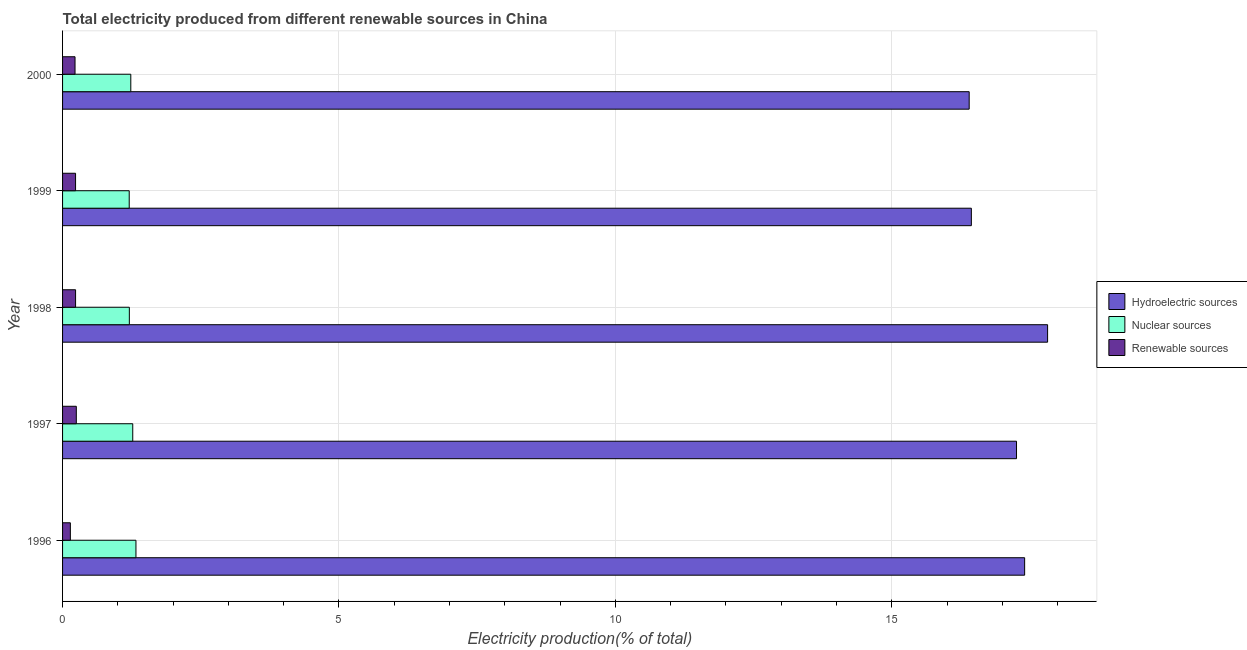How many different coloured bars are there?
Your answer should be compact. 3. Are the number of bars per tick equal to the number of legend labels?
Ensure brevity in your answer.  Yes. What is the label of the 3rd group of bars from the top?
Your answer should be compact. 1998. In how many cases, is the number of bars for a given year not equal to the number of legend labels?
Your answer should be very brief. 0. What is the percentage of electricity produced by hydroelectric sources in 2000?
Ensure brevity in your answer.  16.4. Across all years, what is the maximum percentage of electricity produced by nuclear sources?
Your answer should be compact. 1.33. Across all years, what is the minimum percentage of electricity produced by nuclear sources?
Your answer should be very brief. 1.21. In which year was the percentage of electricity produced by nuclear sources maximum?
Ensure brevity in your answer.  1996. In which year was the percentage of electricity produced by renewable sources minimum?
Offer a terse response. 1996. What is the total percentage of electricity produced by hydroelectric sources in the graph?
Your answer should be very brief. 85.31. What is the difference between the percentage of electricity produced by hydroelectric sources in 1998 and that in 2000?
Keep it short and to the point. 1.42. What is the difference between the percentage of electricity produced by nuclear sources in 2000 and the percentage of electricity produced by renewable sources in 1996?
Your answer should be very brief. 1.09. What is the average percentage of electricity produced by hydroelectric sources per year?
Ensure brevity in your answer.  17.06. In the year 1996, what is the difference between the percentage of electricity produced by renewable sources and percentage of electricity produced by nuclear sources?
Offer a very short reply. -1.19. What is the ratio of the percentage of electricity produced by renewable sources in 1999 to that in 2000?
Offer a terse response. 1.04. Is the percentage of electricity produced by hydroelectric sources in 1997 less than that in 1999?
Your response must be concise. No. Is the difference between the percentage of electricity produced by renewable sources in 1997 and 1998 greater than the difference between the percentage of electricity produced by hydroelectric sources in 1997 and 1998?
Your answer should be very brief. Yes. What is the difference between the highest and the second highest percentage of electricity produced by renewable sources?
Give a very brief answer. 0.01. What is the difference between the highest and the lowest percentage of electricity produced by renewable sources?
Your response must be concise. 0.11. Is the sum of the percentage of electricity produced by renewable sources in 1997 and 1999 greater than the maximum percentage of electricity produced by nuclear sources across all years?
Give a very brief answer. No. What does the 3rd bar from the top in 1999 represents?
Your answer should be very brief. Hydroelectric sources. What does the 2nd bar from the bottom in 1999 represents?
Ensure brevity in your answer.  Nuclear sources. Is it the case that in every year, the sum of the percentage of electricity produced by hydroelectric sources and percentage of electricity produced by nuclear sources is greater than the percentage of electricity produced by renewable sources?
Your response must be concise. Yes. How many years are there in the graph?
Provide a short and direct response. 5. What is the difference between two consecutive major ticks on the X-axis?
Ensure brevity in your answer.  5. Are the values on the major ticks of X-axis written in scientific E-notation?
Offer a terse response. No. Does the graph contain any zero values?
Ensure brevity in your answer.  No. Does the graph contain grids?
Give a very brief answer. Yes. How many legend labels are there?
Give a very brief answer. 3. What is the title of the graph?
Your response must be concise. Total electricity produced from different renewable sources in China. What is the label or title of the Y-axis?
Your response must be concise. Year. What is the Electricity production(% of total) of Hydroelectric sources in 1996?
Ensure brevity in your answer.  17.4. What is the Electricity production(% of total) of Nuclear sources in 1996?
Provide a short and direct response. 1.33. What is the Electricity production(% of total) of Renewable sources in 1996?
Ensure brevity in your answer.  0.14. What is the Electricity production(% of total) of Hydroelectric sources in 1997?
Give a very brief answer. 17.26. What is the Electricity production(% of total) in Nuclear sources in 1997?
Provide a short and direct response. 1.27. What is the Electricity production(% of total) in Renewable sources in 1997?
Offer a very short reply. 0.25. What is the Electricity production(% of total) of Hydroelectric sources in 1998?
Provide a succinct answer. 17.82. What is the Electricity production(% of total) of Nuclear sources in 1998?
Your answer should be compact. 1.21. What is the Electricity production(% of total) of Renewable sources in 1998?
Give a very brief answer. 0.24. What is the Electricity production(% of total) in Hydroelectric sources in 1999?
Offer a very short reply. 16.44. What is the Electricity production(% of total) of Nuclear sources in 1999?
Your answer should be compact. 1.21. What is the Electricity production(% of total) of Renewable sources in 1999?
Your answer should be compact. 0.24. What is the Electricity production(% of total) in Hydroelectric sources in 2000?
Offer a very short reply. 16.4. What is the Electricity production(% of total) of Nuclear sources in 2000?
Provide a succinct answer. 1.23. What is the Electricity production(% of total) in Renewable sources in 2000?
Make the answer very short. 0.23. Across all years, what is the maximum Electricity production(% of total) of Hydroelectric sources?
Your response must be concise. 17.82. Across all years, what is the maximum Electricity production(% of total) in Nuclear sources?
Your answer should be very brief. 1.33. Across all years, what is the maximum Electricity production(% of total) in Renewable sources?
Provide a succinct answer. 0.25. Across all years, what is the minimum Electricity production(% of total) of Hydroelectric sources?
Your response must be concise. 16.4. Across all years, what is the minimum Electricity production(% of total) of Nuclear sources?
Keep it short and to the point. 1.21. Across all years, what is the minimum Electricity production(% of total) in Renewable sources?
Provide a succinct answer. 0.14. What is the total Electricity production(% of total) in Hydroelectric sources in the graph?
Ensure brevity in your answer.  85.31. What is the total Electricity production(% of total) of Nuclear sources in the graph?
Provide a succinct answer. 6.24. What is the total Electricity production(% of total) of Renewable sources in the graph?
Provide a short and direct response. 1.09. What is the difference between the Electricity production(% of total) of Hydroelectric sources in 1996 and that in 1997?
Offer a very short reply. 0.15. What is the difference between the Electricity production(% of total) of Nuclear sources in 1996 and that in 1997?
Offer a very short reply. 0.06. What is the difference between the Electricity production(% of total) in Renewable sources in 1996 and that in 1997?
Your response must be concise. -0.11. What is the difference between the Electricity production(% of total) in Hydroelectric sources in 1996 and that in 1998?
Keep it short and to the point. -0.42. What is the difference between the Electricity production(% of total) in Nuclear sources in 1996 and that in 1998?
Give a very brief answer. 0.12. What is the difference between the Electricity production(% of total) in Renewable sources in 1996 and that in 1998?
Your answer should be very brief. -0.09. What is the difference between the Electricity production(% of total) in Hydroelectric sources in 1996 and that in 1999?
Your response must be concise. 0.96. What is the difference between the Electricity production(% of total) in Nuclear sources in 1996 and that in 1999?
Make the answer very short. 0.12. What is the difference between the Electricity production(% of total) of Renewable sources in 1996 and that in 1999?
Your answer should be compact. -0.09. What is the difference between the Electricity production(% of total) in Hydroelectric sources in 1996 and that in 2000?
Provide a short and direct response. 1. What is the difference between the Electricity production(% of total) in Nuclear sources in 1996 and that in 2000?
Your response must be concise. 0.09. What is the difference between the Electricity production(% of total) of Renewable sources in 1996 and that in 2000?
Offer a very short reply. -0.08. What is the difference between the Electricity production(% of total) of Hydroelectric sources in 1997 and that in 1998?
Ensure brevity in your answer.  -0.56. What is the difference between the Electricity production(% of total) in Nuclear sources in 1997 and that in 1998?
Your response must be concise. 0.06. What is the difference between the Electricity production(% of total) in Renewable sources in 1997 and that in 1998?
Keep it short and to the point. 0.01. What is the difference between the Electricity production(% of total) of Hydroelectric sources in 1997 and that in 1999?
Give a very brief answer. 0.82. What is the difference between the Electricity production(% of total) in Nuclear sources in 1997 and that in 1999?
Make the answer very short. 0.06. What is the difference between the Electricity production(% of total) in Renewable sources in 1997 and that in 1999?
Offer a terse response. 0.01. What is the difference between the Electricity production(% of total) in Hydroelectric sources in 1997 and that in 2000?
Give a very brief answer. 0.86. What is the difference between the Electricity production(% of total) of Nuclear sources in 1997 and that in 2000?
Provide a short and direct response. 0.04. What is the difference between the Electricity production(% of total) in Renewable sources in 1997 and that in 2000?
Offer a very short reply. 0.02. What is the difference between the Electricity production(% of total) of Hydroelectric sources in 1998 and that in 1999?
Keep it short and to the point. 1.38. What is the difference between the Electricity production(% of total) in Nuclear sources in 1998 and that in 1999?
Provide a succinct answer. 0. What is the difference between the Electricity production(% of total) in Hydroelectric sources in 1998 and that in 2000?
Provide a succinct answer. 1.42. What is the difference between the Electricity production(% of total) in Nuclear sources in 1998 and that in 2000?
Your response must be concise. -0.03. What is the difference between the Electricity production(% of total) of Renewable sources in 1998 and that in 2000?
Keep it short and to the point. 0.01. What is the difference between the Electricity production(% of total) of Hydroelectric sources in 1999 and that in 2000?
Your answer should be compact. 0.04. What is the difference between the Electricity production(% of total) of Nuclear sources in 1999 and that in 2000?
Provide a succinct answer. -0.03. What is the difference between the Electricity production(% of total) of Renewable sources in 1999 and that in 2000?
Provide a short and direct response. 0.01. What is the difference between the Electricity production(% of total) in Hydroelectric sources in 1996 and the Electricity production(% of total) in Nuclear sources in 1997?
Offer a terse response. 16.13. What is the difference between the Electricity production(% of total) in Hydroelectric sources in 1996 and the Electricity production(% of total) in Renewable sources in 1997?
Ensure brevity in your answer.  17.15. What is the difference between the Electricity production(% of total) of Nuclear sources in 1996 and the Electricity production(% of total) of Renewable sources in 1997?
Offer a terse response. 1.08. What is the difference between the Electricity production(% of total) of Hydroelectric sources in 1996 and the Electricity production(% of total) of Nuclear sources in 1998?
Your answer should be compact. 16.19. What is the difference between the Electricity production(% of total) of Hydroelectric sources in 1996 and the Electricity production(% of total) of Renewable sources in 1998?
Keep it short and to the point. 17.17. What is the difference between the Electricity production(% of total) in Nuclear sources in 1996 and the Electricity production(% of total) in Renewable sources in 1998?
Offer a very short reply. 1.09. What is the difference between the Electricity production(% of total) in Hydroelectric sources in 1996 and the Electricity production(% of total) in Nuclear sources in 1999?
Your answer should be very brief. 16.2. What is the difference between the Electricity production(% of total) in Hydroelectric sources in 1996 and the Electricity production(% of total) in Renewable sources in 1999?
Provide a short and direct response. 17.17. What is the difference between the Electricity production(% of total) of Nuclear sources in 1996 and the Electricity production(% of total) of Renewable sources in 1999?
Your response must be concise. 1.09. What is the difference between the Electricity production(% of total) in Hydroelectric sources in 1996 and the Electricity production(% of total) in Nuclear sources in 2000?
Make the answer very short. 16.17. What is the difference between the Electricity production(% of total) of Hydroelectric sources in 1996 and the Electricity production(% of total) of Renewable sources in 2000?
Give a very brief answer. 17.18. What is the difference between the Electricity production(% of total) of Nuclear sources in 1996 and the Electricity production(% of total) of Renewable sources in 2000?
Provide a succinct answer. 1.1. What is the difference between the Electricity production(% of total) in Hydroelectric sources in 1997 and the Electricity production(% of total) in Nuclear sources in 1998?
Provide a short and direct response. 16.05. What is the difference between the Electricity production(% of total) in Hydroelectric sources in 1997 and the Electricity production(% of total) in Renewable sources in 1998?
Provide a short and direct response. 17.02. What is the difference between the Electricity production(% of total) of Nuclear sources in 1997 and the Electricity production(% of total) of Renewable sources in 1998?
Ensure brevity in your answer.  1.03. What is the difference between the Electricity production(% of total) in Hydroelectric sources in 1997 and the Electricity production(% of total) in Nuclear sources in 1999?
Provide a succinct answer. 16.05. What is the difference between the Electricity production(% of total) in Hydroelectric sources in 1997 and the Electricity production(% of total) in Renewable sources in 1999?
Your answer should be compact. 17.02. What is the difference between the Electricity production(% of total) in Nuclear sources in 1997 and the Electricity production(% of total) in Renewable sources in 1999?
Your answer should be compact. 1.03. What is the difference between the Electricity production(% of total) of Hydroelectric sources in 1997 and the Electricity production(% of total) of Nuclear sources in 2000?
Your response must be concise. 16.02. What is the difference between the Electricity production(% of total) in Hydroelectric sources in 1997 and the Electricity production(% of total) in Renewable sources in 2000?
Offer a terse response. 17.03. What is the difference between the Electricity production(% of total) in Nuclear sources in 1997 and the Electricity production(% of total) in Renewable sources in 2000?
Offer a terse response. 1.04. What is the difference between the Electricity production(% of total) of Hydroelectric sources in 1998 and the Electricity production(% of total) of Nuclear sources in 1999?
Your answer should be compact. 16.61. What is the difference between the Electricity production(% of total) in Hydroelectric sources in 1998 and the Electricity production(% of total) in Renewable sources in 1999?
Your response must be concise. 17.58. What is the difference between the Electricity production(% of total) in Nuclear sources in 1998 and the Electricity production(% of total) in Renewable sources in 1999?
Offer a terse response. 0.97. What is the difference between the Electricity production(% of total) of Hydroelectric sources in 1998 and the Electricity production(% of total) of Nuclear sources in 2000?
Offer a terse response. 16.58. What is the difference between the Electricity production(% of total) in Hydroelectric sources in 1998 and the Electricity production(% of total) in Renewable sources in 2000?
Your answer should be very brief. 17.59. What is the difference between the Electricity production(% of total) of Nuclear sources in 1998 and the Electricity production(% of total) of Renewable sources in 2000?
Provide a succinct answer. 0.98. What is the difference between the Electricity production(% of total) in Hydroelectric sources in 1999 and the Electricity production(% of total) in Nuclear sources in 2000?
Provide a succinct answer. 15.2. What is the difference between the Electricity production(% of total) in Hydroelectric sources in 1999 and the Electricity production(% of total) in Renewable sources in 2000?
Your answer should be very brief. 16.21. What is the difference between the Electricity production(% of total) in Nuclear sources in 1999 and the Electricity production(% of total) in Renewable sources in 2000?
Give a very brief answer. 0.98. What is the average Electricity production(% of total) in Hydroelectric sources per year?
Offer a terse response. 17.06. What is the average Electricity production(% of total) of Nuclear sources per year?
Your response must be concise. 1.25. What is the average Electricity production(% of total) of Renewable sources per year?
Give a very brief answer. 0.22. In the year 1996, what is the difference between the Electricity production(% of total) in Hydroelectric sources and Electricity production(% of total) in Nuclear sources?
Your answer should be very brief. 16.07. In the year 1996, what is the difference between the Electricity production(% of total) in Hydroelectric sources and Electricity production(% of total) in Renewable sources?
Provide a succinct answer. 17.26. In the year 1996, what is the difference between the Electricity production(% of total) in Nuclear sources and Electricity production(% of total) in Renewable sources?
Provide a short and direct response. 1.19. In the year 1997, what is the difference between the Electricity production(% of total) of Hydroelectric sources and Electricity production(% of total) of Nuclear sources?
Provide a short and direct response. 15.99. In the year 1997, what is the difference between the Electricity production(% of total) of Hydroelectric sources and Electricity production(% of total) of Renewable sources?
Give a very brief answer. 17.01. In the year 1997, what is the difference between the Electricity production(% of total) of Nuclear sources and Electricity production(% of total) of Renewable sources?
Make the answer very short. 1.02. In the year 1998, what is the difference between the Electricity production(% of total) of Hydroelectric sources and Electricity production(% of total) of Nuclear sources?
Your answer should be very brief. 16.61. In the year 1998, what is the difference between the Electricity production(% of total) of Hydroelectric sources and Electricity production(% of total) of Renewable sources?
Offer a very short reply. 17.58. In the year 1998, what is the difference between the Electricity production(% of total) in Nuclear sources and Electricity production(% of total) in Renewable sources?
Your answer should be compact. 0.97. In the year 1999, what is the difference between the Electricity production(% of total) in Hydroelectric sources and Electricity production(% of total) in Nuclear sources?
Your response must be concise. 15.23. In the year 1999, what is the difference between the Electricity production(% of total) in Hydroelectric sources and Electricity production(% of total) in Renewable sources?
Provide a short and direct response. 16.2. In the year 1999, what is the difference between the Electricity production(% of total) of Nuclear sources and Electricity production(% of total) of Renewable sources?
Provide a succinct answer. 0.97. In the year 2000, what is the difference between the Electricity production(% of total) in Hydroelectric sources and Electricity production(% of total) in Nuclear sources?
Provide a succinct answer. 15.17. In the year 2000, what is the difference between the Electricity production(% of total) of Hydroelectric sources and Electricity production(% of total) of Renewable sources?
Your response must be concise. 16.17. In the year 2000, what is the difference between the Electricity production(% of total) in Nuclear sources and Electricity production(% of total) in Renewable sources?
Provide a succinct answer. 1.01. What is the ratio of the Electricity production(% of total) of Hydroelectric sources in 1996 to that in 1997?
Offer a very short reply. 1.01. What is the ratio of the Electricity production(% of total) in Nuclear sources in 1996 to that in 1997?
Your answer should be very brief. 1.05. What is the ratio of the Electricity production(% of total) of Renewable sources in 1996 to that in 1997?
Keep it short and to the point. 0.57. What is the ratio of the Electricity production(% of total) of Hydroelectric sources in 1996 to that in 1998?
Your answer should be very brief. 0.98. What is the ratio of the Electricity production(% of total) in Nuclear sources in 1996 to that in 1998?
Provide a short and direct response. 1.1. What is the ratio of the Electricity production(% of total) in Renewable sources in 1996 to that in 1998?
Keep it short and to the point. 0.6. What is the ratio of the Electricity production(% of total) of Hydroelectric sources in 1996 to that in 1999?
Your response must be concise. 1.06. What is the ratio of the Electricity production(% of total) in Nuclear sources in 1996 to that in 1999?
Make the answer very short. 1.1. What is the ratio of the Electricity production(% of total) in Renewable sources in 1996 to that in 1999?
Your response must be concise. 0.6. What is the ratio of the Electricity production(% of total) of Hydroelectric sources in 1996 to that in 2000?
Offer a terse response. 1.06. What is the ratio of the Electricity production(% of total) of Nuclear sources in 1996 to that in 2000?
Ensure brevity in your answer.  1.08. What is the ratio of the Electricity production(% of total) in Renewable sources in 1996 to that in 2000?
Ensure brevity in your answer.  0.63. What is the ratio of the Electricity production(% of total) of Hydroelectric sources in 1997 to that in 1998?
Ensure brevity in your answer.  0.97. What is the ratio of the Electricity production(% of total) in Nuclear sources in 1997 to that in 1998?
Your answer should be compact. 1.05. What is the ratio of the Electricity production(% of total) in Renewable sources in 1997 to that in 1998?
Give a very brief answer. 1.06. What is the ratio of the Electricity production(% of total) in Hydroelectric sources in 1997 to that in 1999?
Offer a very short reply. 1.05. What is the ratio of the Electricity production(% of total) in Nuclear sources in 1997 to that in 1999?
Keep it short and to the point. 1.05. What is the ratio of the Electricity production(% of total) of Renewable sources in 1997 to that in 1999?
Your answer should be compact. 1.06. What is the ratio of the Electricity production(% of total) in Hydroelectric sources in 1997 to that in 2000?
Offer a terse response. 1.05. What is the ratio of the Electricity production(% of total) in Nuclear sources in 1997 to that in 2000?
Make the answer very short. 1.03. What is the ratio of the Electricity production(% of total) in Renewable sources in 1997 to that in 2000?
Make the answer very short. 1.1. What is the ratio of the Electricity production(% of total) in Hydroelectric sources in 1998 to that in 1999?
Ensure brevity in your answer.  1.08. What is the ratio of the Electricity production(% of total) of Nuclear sources in 1998 to that in 1999?
Provide a short and direct response. 1. What is the ratio of the Electricity production(% of total) in Hydroelectric sources in 1998 to that in 2000?
Make the answer very short. 1.09. What is the ratio of the Electricity production(% of total) in Nuclear sources in 1998 to that in 2000?
Ensure brevity in your answer.  0.98. What is the ratio of the Electricity production(% of total) in Renewable sources in 1998 to that in 2000?
Your answer should be very brief. 1.04. What is the ratio of the Electricity production(% of total) of Hydroelectric sources in 1999 to that in 2000?
Offer a terse response. 1. What is the ratio of the Electricity production(% of total) of Nuclear sources in 1999 to that in 2000?
Your answer should be very brief. 0.98. What is the ratio of the Electricity production(% of total) of Renewable sources in 1999 to that in 2000?
Your response must be concise. 1.04. What is the difference between the highest and the second highest Electricity production(% of total) of Hydroelectric sources?
Offer a terse response. 0.42. What is the difference between the highest and the second highest Electricity production(% of total) of Nuclear sources?
Keep it short and to the point. 0.06. What is the difference between the highest and the second highest Electricity production(% of total) in Renewable sources?
Give a very brief answer. 0.01. What is the difference between the highest and the lowest Electricity production(% of total) in Hydroelectric sources?
Your answer should be very brief. 1.42. What is the difference between the highest and the lowest Electricity production(% of total) of Nuclear sources?
Offer a terse response. 0.12. What is the difference between the highest and the lowest Electricity production(% of total) in Renewable sources?
Your response must be concise. 0.11. 